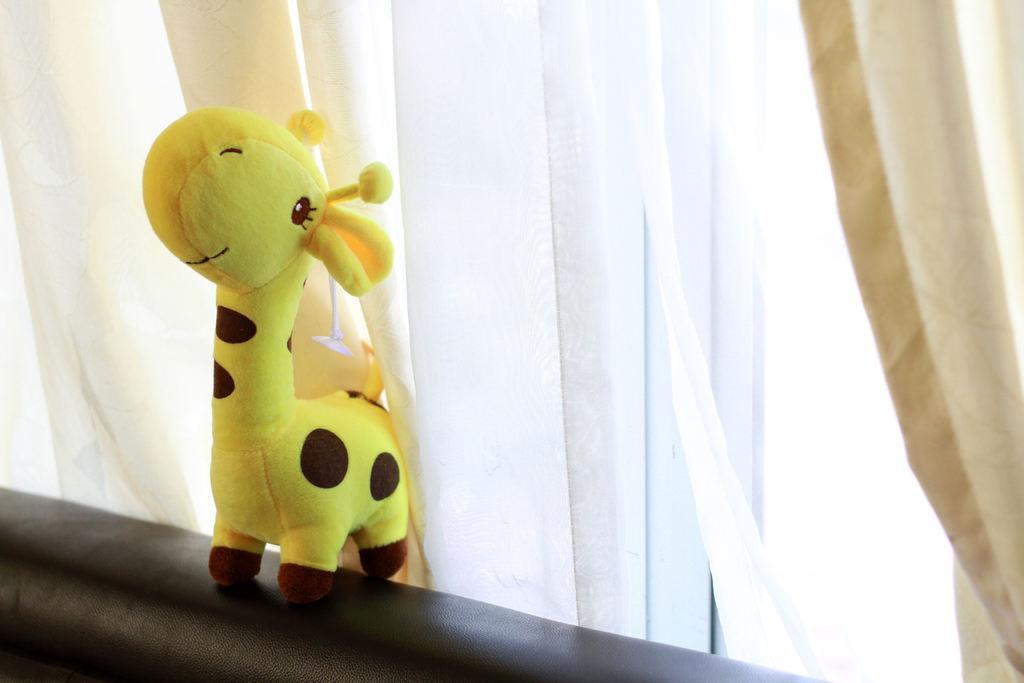How would you summarize this image in a sentence or two? In this picture I can observe a toy on the left side. This toy is in yellow and black color. In the background I can observe white color curtains. 